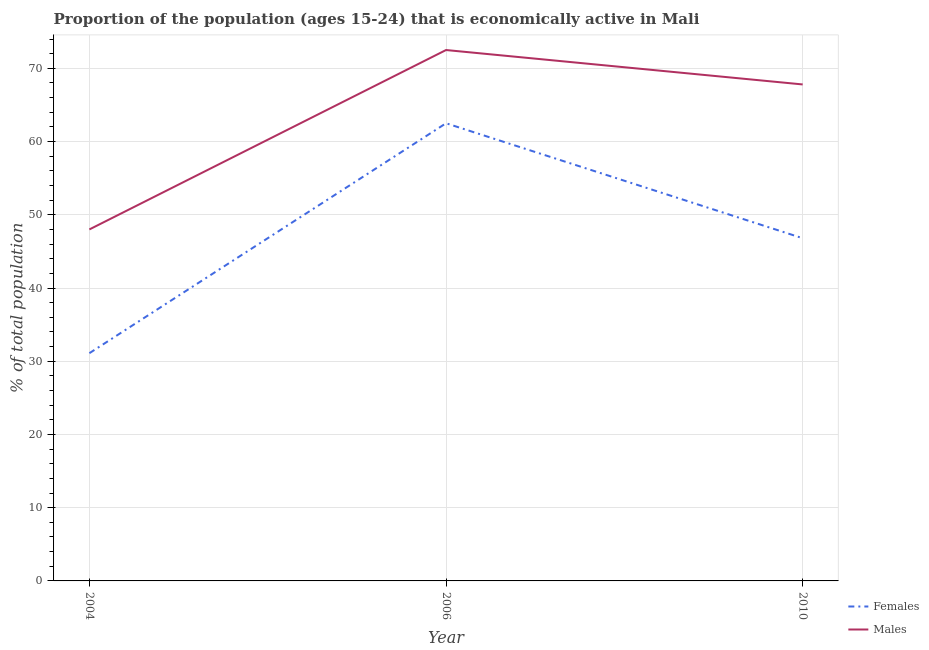Is the number of lines equal to the number of legend labels?
Provide a succinct answer. Yes. What is the percentage of economically active female population in 2010?
Your response must be concise. 46.8. Across all years, what is the maximum percentage of economically active female population?
Your response must be concise. 62.5. Across all years, what is the minimum percentage of economically active female population?
Provide a short and direct response. 31.1. In which year was the percentage of economically active male population minimum?
Keep it short and to the point. 2004. What is the total percentage of economically active male population in the graph?
Offer a very short reply. 188.3. What is the difference between the percentage of economically active male population in 2006 and that in 2010?
Your response must be concise. 4.7. What is the difference between the percentage of economically active female population in 2006 and the percentage of economically active male population in 2010?
Offer a terse response. -5.3. What is the average percentage of economically active female population per year?
Your answer should be very brief. 46.8. What is the ratio of the percentage of economically active female population in 2006 to that in 2010?
Offer a very short reply. 1.34. Is the difference between the percentage of economically active female population in 2006 and 2010 greater than the difference between the percentage of economically active male population in 2006 and 2010?
Offer a terse response. Yes. What is the difference between the highest and the second highest percentage of economically active female population?
Keep it short and to the point. 15.7. What is the difference between the highest and the lowest percentage of economically active female population?
Your response must be concise. 31.4. In how many years, is the percentage of economically active female population greater than the average percentage of economically active female population taken over all years?
Ensure brevity in your answer.  1. Is the percentage of economically active female population strictly greater than the percentage of economically active male population over the years?
Ensure brevity in your answer.  No. Is the percentage of economically active female population strictly less than the percentage of economically active male population over the years?
Ensure brevity in your answer.  Yes. Are the values on the major ticks of Y-axis written in scientific E-notation?
Your response must be concise. No. Does the graph contain any zero values?
Provide a succinct answer. No. How are the legend labels stacked?
Offer a very short reply. Vertical. What is the title of the graph?
Ensure brevity in your answer.  Proportion of the population (ages 15-24) that is economically active in Mali. Does "RDB nonconcessional" appear as one of the legend labels in the graph?
Your response must be concise. No. What is the label or title of the X-axis?
Offer a terse response. Year. What is the label or title of the Y-axis?
Provide a succinct answer. % of total population. What is the % of total population in Females in 2004?
Make the answer very short. 31.1. What is the % of total population of Males in 2004?
Offer a terse response. 48. What is the % of total population in Females in 2006?
Give a very brief answer. 62.5. What is the % of total population of Males in 2006?
Provide a short and direct response. 72.5. What is the % of total population of Females in 2010?
Give a very brief answer. 46.8. What is the % of total population in Males in 2010?
Your response must be concise. 67.8. Across all years, what is the maximum % of total population of Females?
Your response must be concise. 62.5. Across all years, what is the maximum % of total population of Males?
Provide a succinct answer. 72.5. Across all years, what is the minimum % of total population in Females?
Your answer should be very brief. 31.1. What is the total % of total population in Females in the graph?
Provide a short and direct response. 140.4. What is the total % of total population in Males in the graph?
Give a very brief answer. 188.3. What is the difference between the % of total population of Females in 2004 and that in 2006?
Offer a very short reply. -31.4. What is the difference between the % of total population of Males in 2004 and that in 2006?
Your answer should be very brief. -24.5. What is the difference between the % of total population in Females in 2004 and that in 2010?
Keep it short and to the point. -15.7. What is the difference between the % of total population of Males in 2004 and that in 2010?
Give a very brief answer. -19.8. What is the difference between the % of total population in Females in 2006 and that in 2010?
Offer a terse response. 15.7. What is the difference between the % of total population in Males in 2006 and that in 2010?
Your answer should be very brief. 4.7. What is the difference between the % of total population in Females in 2004 and the % of total population in Males in 2006?
Provide a succinct answer. -41.4. What is the difference between the % of total population in Females in 2004 and the % of total population in Males in 2010?
Provide a succinct answer. -36.7. What is the difference between the % of total population in Females in 2006 and the % of total population in Males in 2010?
Your answer should be very brief. -5.3. What is the average % of total population in Females per year?
Ensure brevity in your answer.  46.8. What is the average % of total population of Males per year?
Give a very brief answer. 62.77. In the year 2004, what is the difference between the % of total population in Females and % of total population in Males?
Your answer should be compact. -16.9. In the year 2006, what is the difference between the % of total population of Females and % of total population of Males?
Your answer should be compact. -10. In the year 2010, what is the difference between the % of total population of Females and % of total population of Males?
Ensure brevity in your answer.  -21. What is the ratio of the % of total population in Females in 2004 to that in 2006?
Offer a very short reply. 0.5. What is the ratio of the % of total population in Males in 2004 to that in 2006?
Give a very brief answer. 0.66. What is the ratio of the % of total population of Females in 2004 to that in 2010?
Keep it short and to the point. 0.66. What is the ratio of the % of total population in Males in 2004 to that in 2010?
Provide a short and direct response. 0.71. What is the ratio of the % of total population of Females in 2006 to that in 2010?
Offer a terse response. 1.34. What is the ratio of the % of total population of Males in 2006 to that in 2010?
Provide a short and direct response. 1.07. What is the difference between the highest and the second highest % of total population in Females?
Your answer should be very brief. 15.7. What is the difference between the highest and the lowest % of total population of Females?
Ensure brevity in your answer.  31.4. 